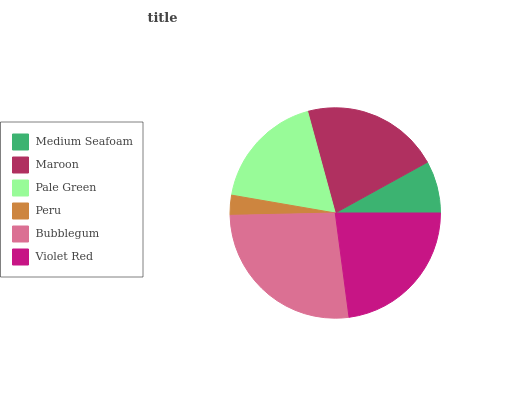Is Peru the minimum?
Answer yes or no. Yes. Is Bubblegum the maximum?
Answer yes or no. Yes. Is Maroon the minimum?
Answer yes or no. No. Is Maroon the maximum?
Answer yes or no. No. Is Maroon greater than Medium Seafoam?
Answer yes or no. Yes. Is Medium Seafoam less than Maroon?
Answer yes or no. Yes. Is Medium Seafoam greater than Maroon?
Answer yes or no. No. Is Maroon less than Medium Seafoam?
Answer yes or no. No. Is Maroon the high median?
Answer yes or no. Yes. Is Pale Green the low median?
Answer yes or no. Yes. Is Peru the high median?
Answer yes or no. No. Is Violet Red the low median?
Answer yes or no. No. 